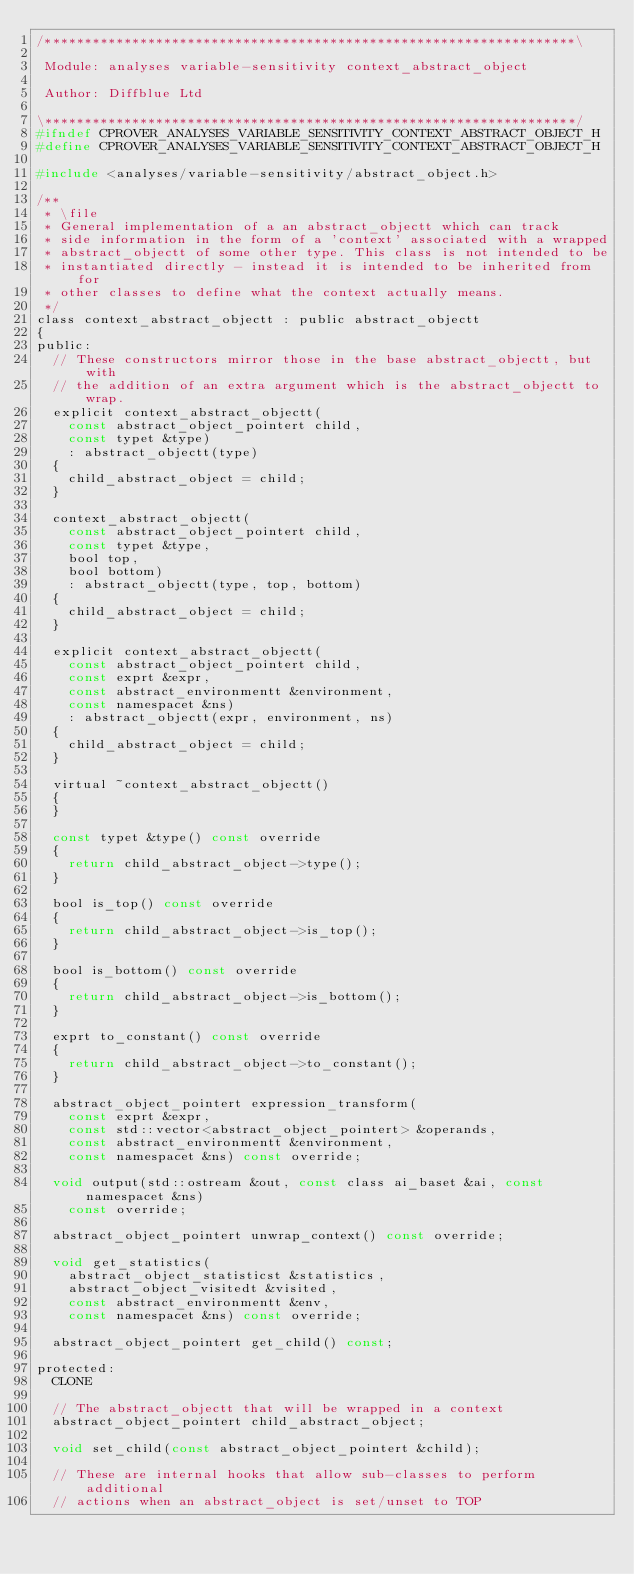<code> <loc_0><loc_0><loc_500><loc_500><_C_>/*******************************************************************\

 Module: analyses variable-sensitivity context_abstract_object

 Author: Diffblue Ltd

\*******************************************************************/
#ifndef CPROVER_ANALYSES_VARIABLE_SENSITIVITY_CONTEXT_ABSTRACT_OBJECT_H
#define CPROVER_ANALYSES_VARIABLE_SENSITIVITY_CONTEXT_ABSTRACT_OBJECT_H

#include <analyses/variable-sensitivity/abstract_object.h>

/**
 * \file
 * General implementation of a an abstract_objectt which can track
 * side information in the form of a 'context' associated with a wrapped
 * abstract_objectt of some other type. This class is not intended to be
 * instantiated directly - instead it is intended to be inherited from for
 * other classes to define what the context actually means.
 */
class context_abstract_objectt : public abstract_objectt
{
public:
  // These constructors mirror those in the base abstract_objectt, but with
  // the addition of an extra argument which is the abstract_objectt to wrap.
  explicit context_abstract_objectt(
    const abstract_object_pointert child,
    const typet &type)
    : abstract_objectt(type)
  {
    child_abstract_object = child;
  }

  context_abstract_objectt(
    const abstract_object_pointert child,
    const typet &type,
    bool top,
    bool bottom)
    : abstract_objectt(type, top, bottom)
  {
    child_abstract_object = child;
  }

  explicit context_abstract_objectt(
    const abstract_object_pointert child,
    const exprt &expr,
    const abstract_environmentt &environment,
    const namespacet &ns)
    : abstract_objectt(expr, environment, ns)
  {
    child_abstract_object = child;
  }

  virtual ~context_abstract_objectt()
  {
  }

  const typet &type() const override
  {
    return child_abstract_object->type();
  }

  bool is_top() const override
  {
    return child_abstract_object->is_top();
  }

  bool is_bottom() const override
  {
    return child_abstract_object->is_bottom();
  }

  exprt to_constant() const override
  {
    return child_abstract_object->to_constant();
  }

  abstract_object_pointert expression_transform(
    const exprt &expr,
    const std::vector<abstract_object_pointert> &operands,
    const abstract_environmentt &environment,
    const namespacet &ns) const override;

  void output(std::ostream &out, const class ai_baset &ai, const namespacet &ns)
    const override;

  abstract_object_pointert unwrap_context() const override;

  void get_statistics(
    abstract_object_statisticst &statistics,
    abstract_object_visitedt &visited,
    const abstract_environmentt &env,
    const namespacet &ns) const override;

  abstract_object_pointert get_child() const;

protected:
  CLONE

  // The abstract_objectt that will be wrapped in a context
  abstract_object_pointert child_abstract_object;

  void set_child(const abstract_object_pointert &child);

  // These are internal hooks that allow sub-classes to perform additional
  // actions when an abstract_object is set/unset to TOP</code> 